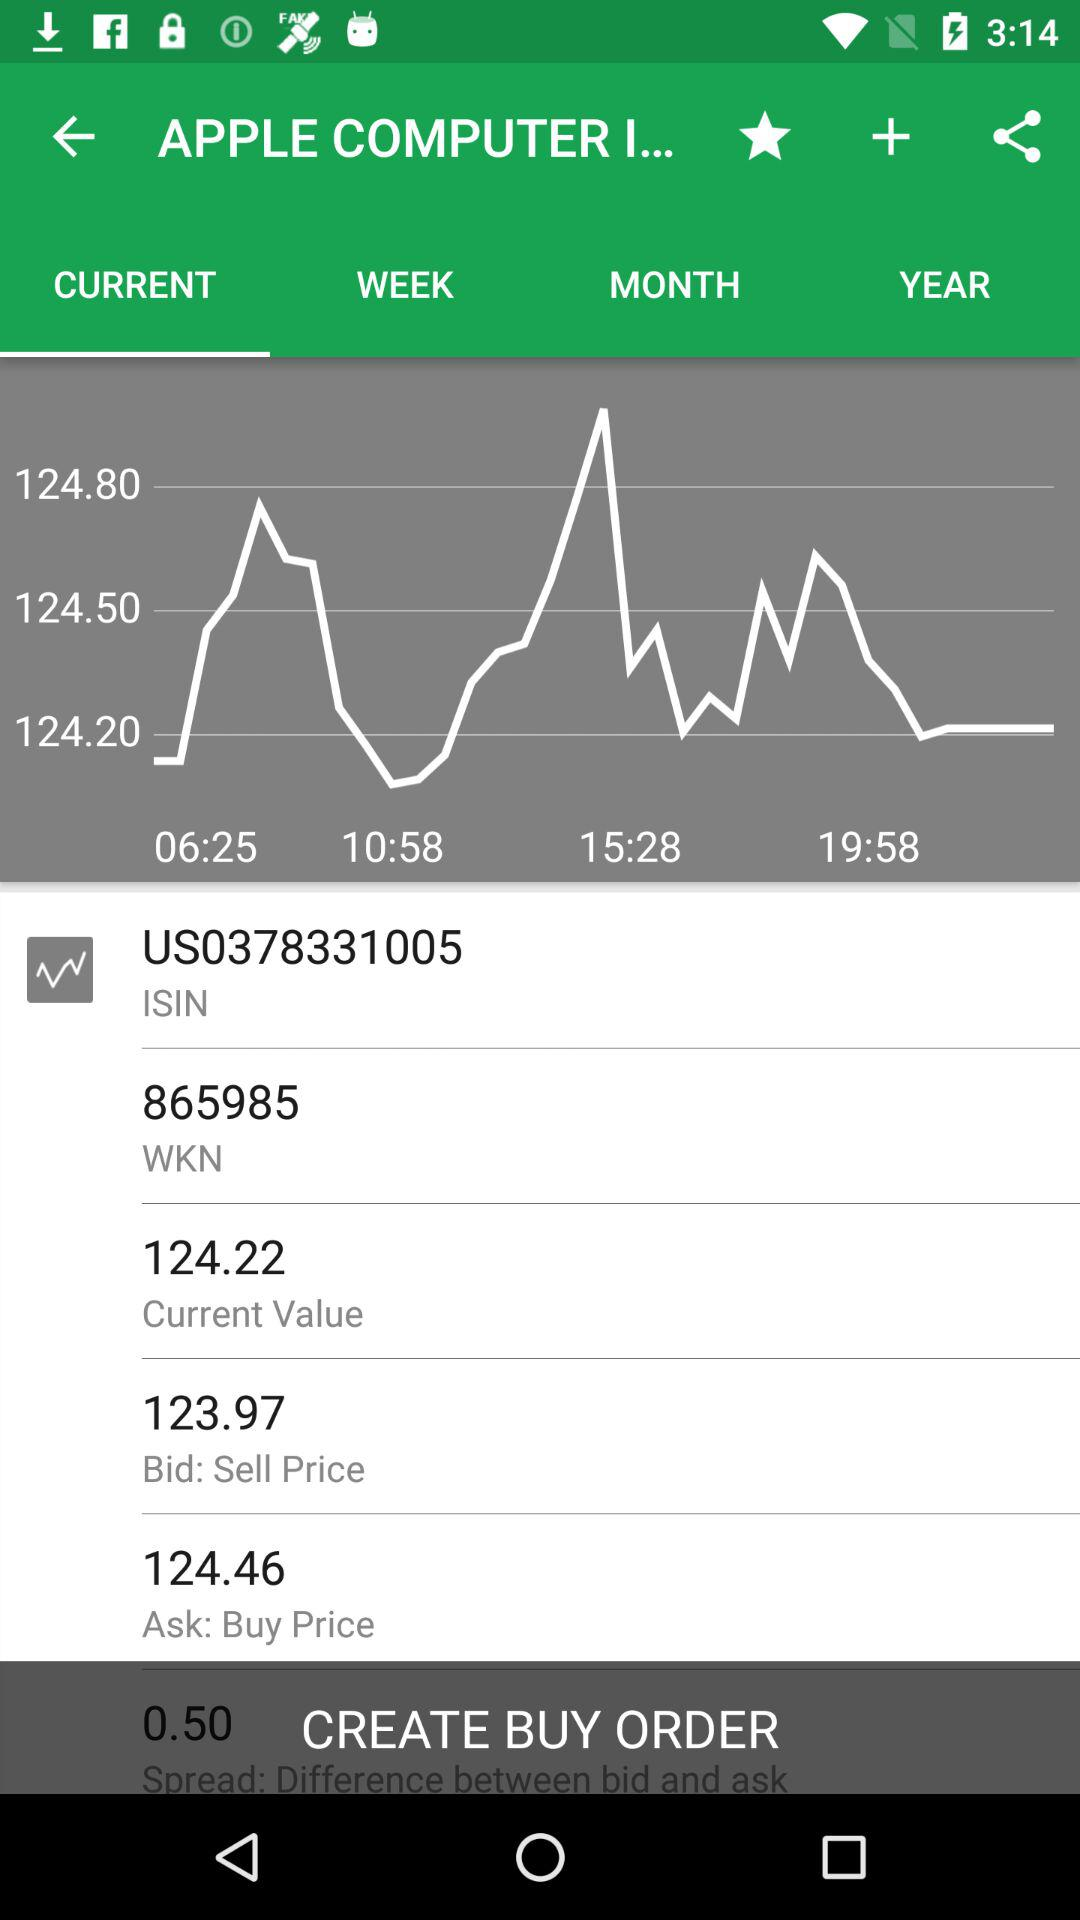What is the current value? The current value is 124.22. 